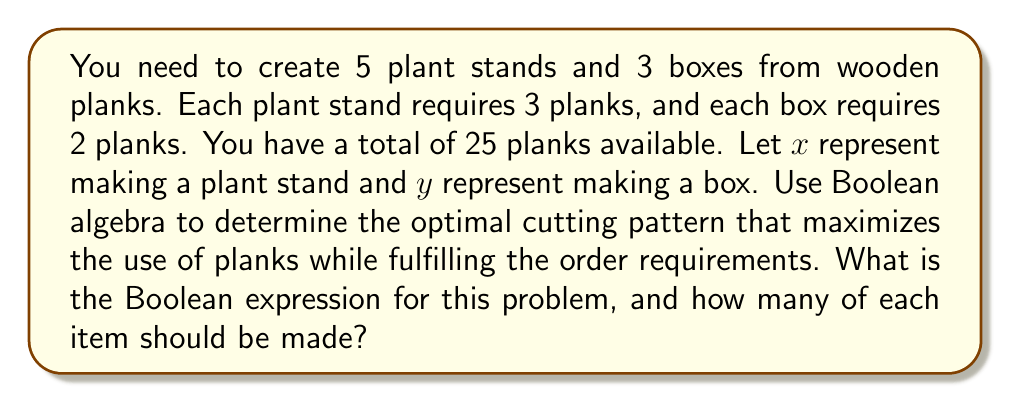Give your solution to this math problem. Let's approach this step-by-step using Boolean algebra:

1. Define the variables:
   $x$: making a plant stand
   $y$: making a box

2. Express the constraints:
   - At least 5 plant stands: $x \geq 5$
   - At least 3 boxes: $y \geq 3$
   - Total planks used must not exceed 25: $3x + 2y \leq 25$

3. Convert these constraints to Boolean expressions:
   $f_1 = (x \geq 5)$
   $f_2 = (y \geq 3)$
   $f_3 = (3x + 2y \leq 25)$

4. The Boolean expression for the problem is the conjunction of these constraints:
   $F = f_1 \cdot f_2 \cdot f_3$

5. To maximize plank usage, we need to find the largest values of $x$ and $y$ that satisfy $F$.

6. Starting with the minimum requirements (5 plant stands and 3 boxes):
   $3(5) + 2(3) = 15 + 6 = 21$ planks

7. We have 4 planks remaining. We can make either:
   - 1 more plant stand (3 planks) and 0 boxes
   - 0 plant stands and 2 more boxes (4 planks)

8. Option 2 uses all available planks and satisfies all constraints.

Therefore, the optimal cutting pattern is to make 5 plant stands and 5 boxes.
Answer: $F = (x \geq 5) \cdot (y \geq 3) \cdot (3x + 2y \leq 25)$; Make 5 plant stands and 5 boxes. 